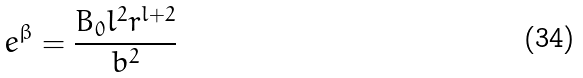Convert formula to latex. <formula><loc_0><loc_0><loc_500><loc_500>e ^ { \beta } = \frac { B _ { 0 } l ^ { 2 } r ^ { l + 2 } } { b ^ { 2 } }</formula> 